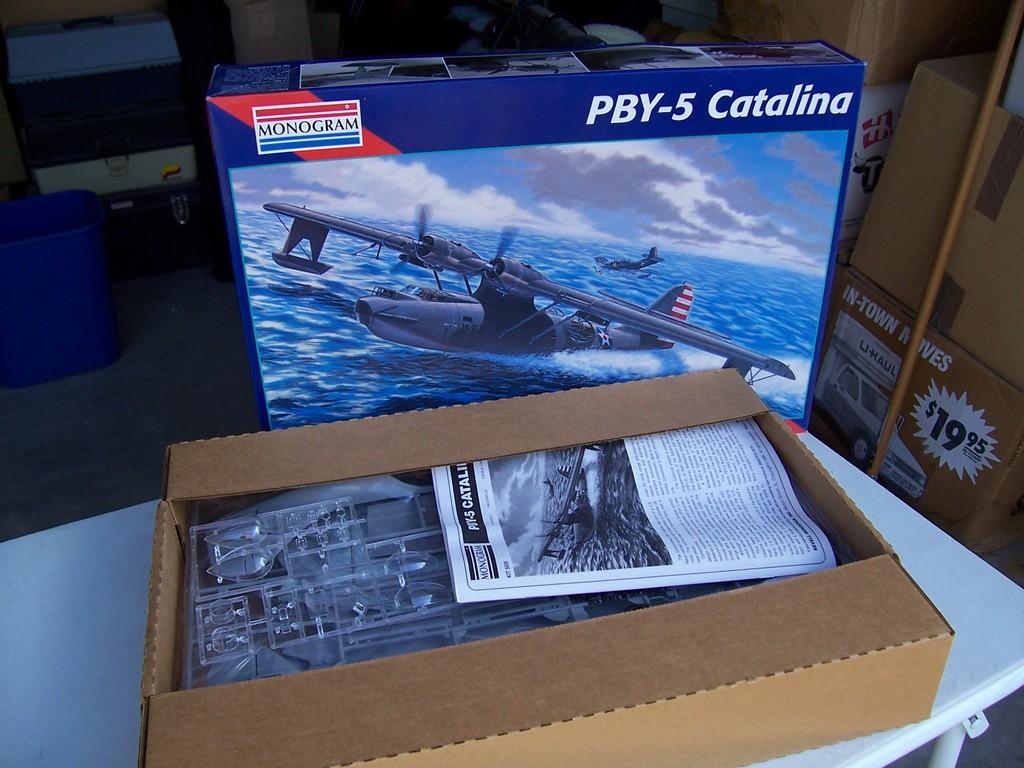What model of cataline is the model?
Your answer should be compact. Pby-5. What brand of model kit is this?
Keep it short and to the point. Monogram. 